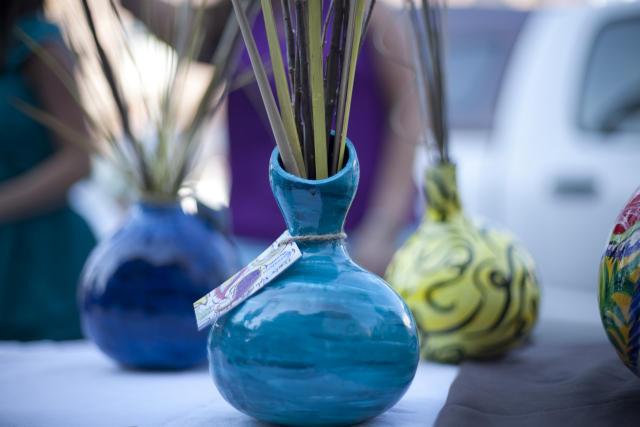Why is there a tag on the vase?
Quick response, please. It is for sale. How many vases?
Answer briefly. 4. Are there sunflower in the vase?
Write a very short answer. No. 